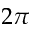<formula> <loc_0><loc_0><loc_500><loc_500>2 \pi</formula> 